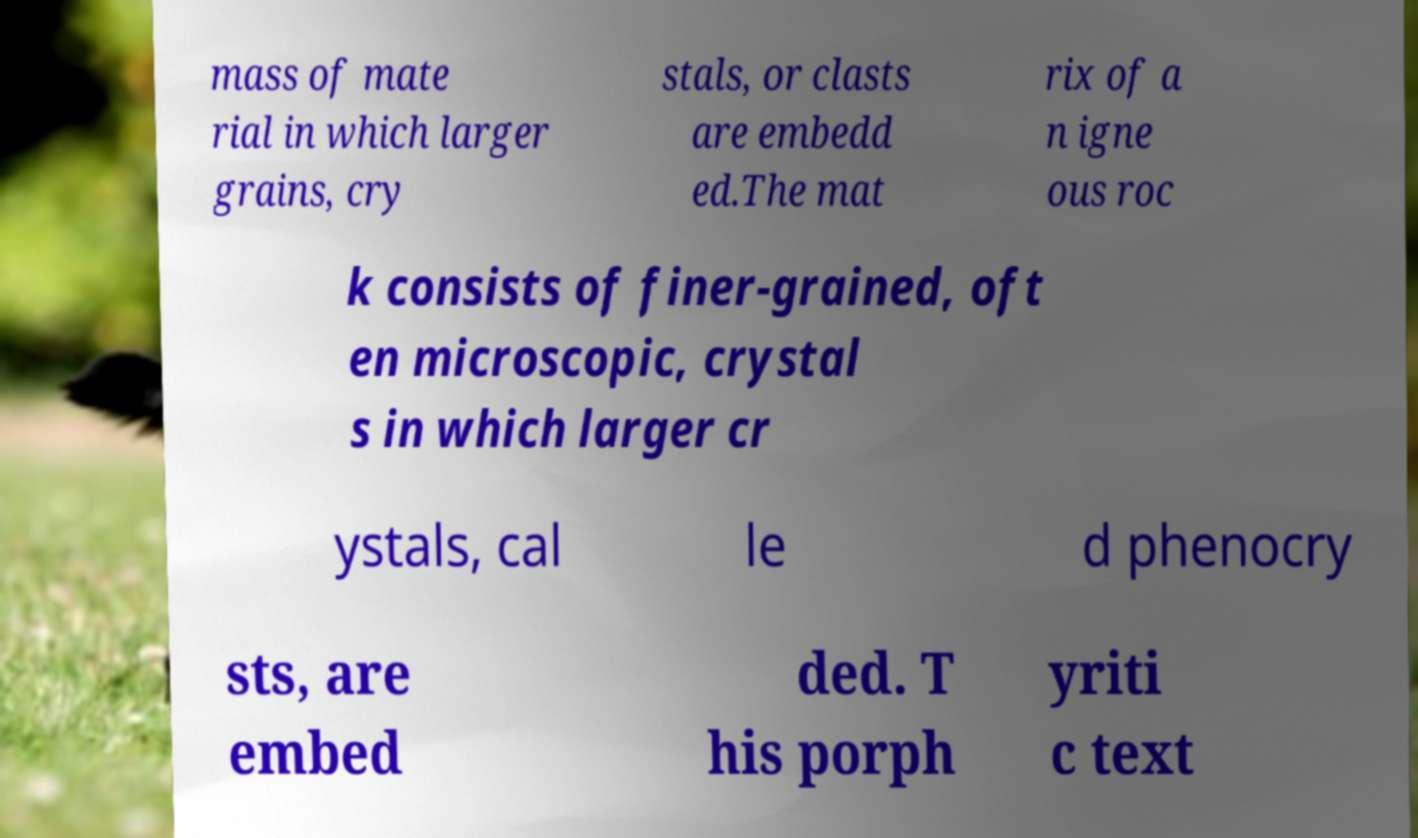Could you assist in decoding the text presented in this image and type it out clearly? mass of mate rial in which larger grains, cry stals, or clasts are embedd ed.The mat rix of a n igne ous roc k consists of finer-grained, oft en microscopic, crystal s in which larger cr ystals, cal le d phenocry sts, are embed ded. T his porph yriti c text 